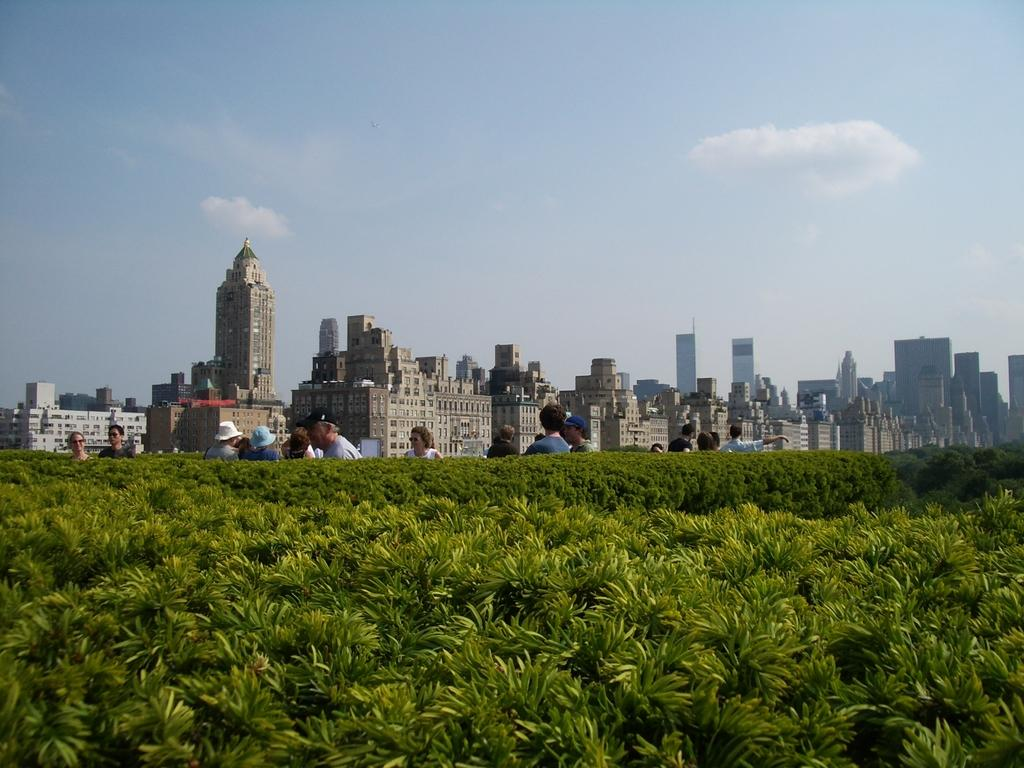What is located in the foreground of the image? There are trees in the foreground of the image. What else can be seen in the image? There are people in the image. What type of structures are visible in the background of the image? There are tall buildings in the background of the image. What part of the natural environment is visible in the image? The sky is visible in the image. Can you tell me how many crates are stacked next to the tall buildings in the image? There are no crates present in the image; it features trees in the foreground, people, tall buildings, and the sky. What type of fang is visible on the actor in the image? There is no actor or fang present in the image. 